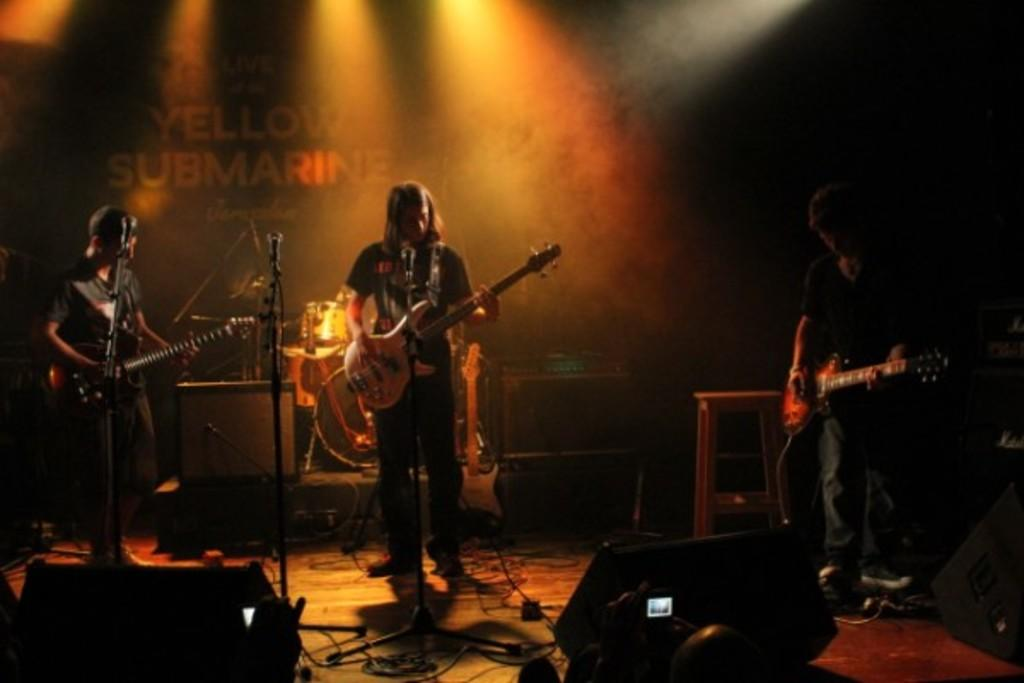What is happening on the stage in the image? There are people on the stage, and they are performing. What are the people doing while performing? They are playing musical instruments. What can be seen behind the people on the stage? There is a banner behind them. What can be seen in the image that might provide illumination? There are lights visible in the image. What type of juice is being served to the audience in the image? There is no juice or audience present in the image; it features people on a stage playing musical instruments. What type of insurance policy is being advertised on the banner behind the performers? There is no mention of insurance or any advertisement on the banner in the image; it simply displays a banner. 